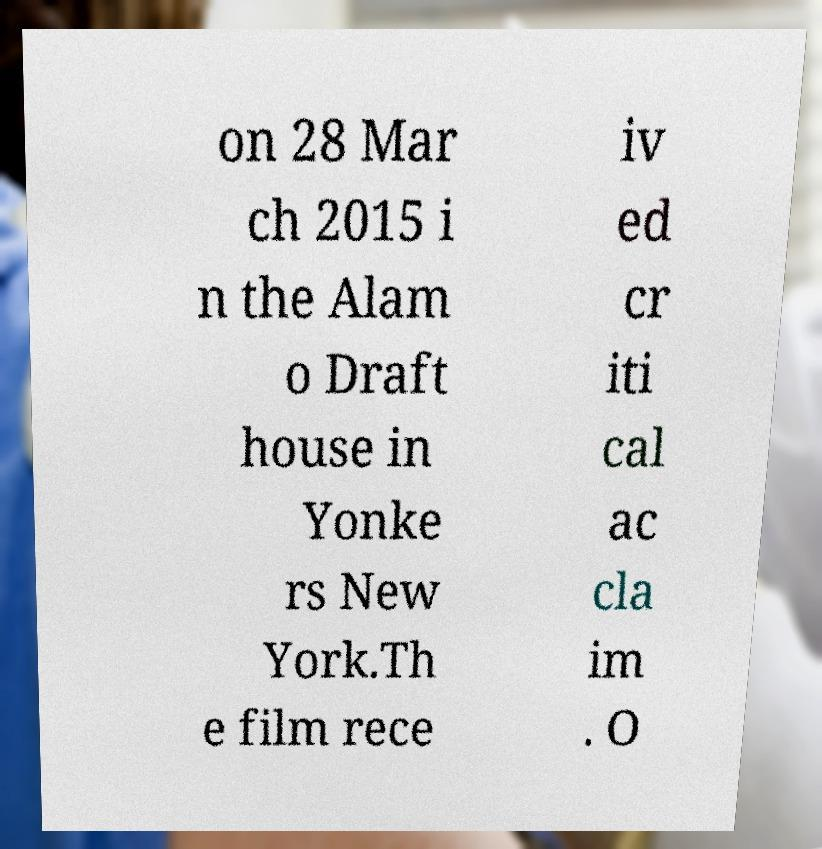Please read and relay the text visible in this image. What does it say? on 28 Mar ch 2015 i n the Alam o Draft house in Yonke rs New York.Th e film rece iv ed cr iti cal ac cla im . O 